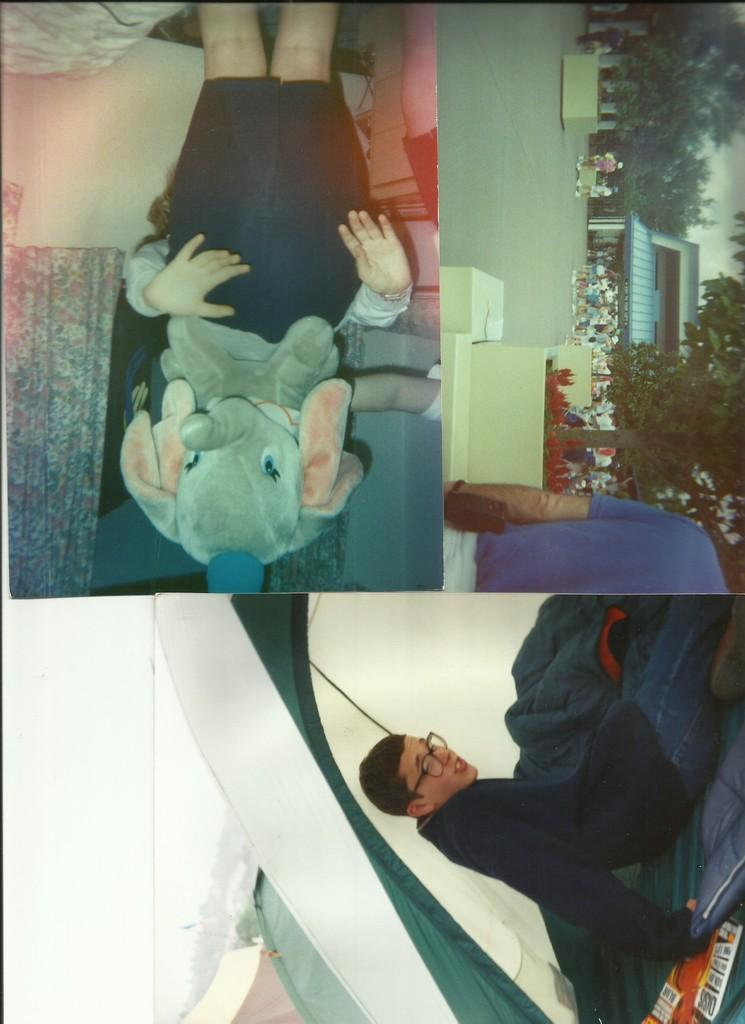What type of image is being described? The image is a collage of photos. How are the photos arranged or presented in the image? The provided facts do not specify the arrangement or presentation of the photos in the collage. What type of brass instrument is being played in the image? There is no brass instrument or any indication of music in the image, as it is a collage of photos. 